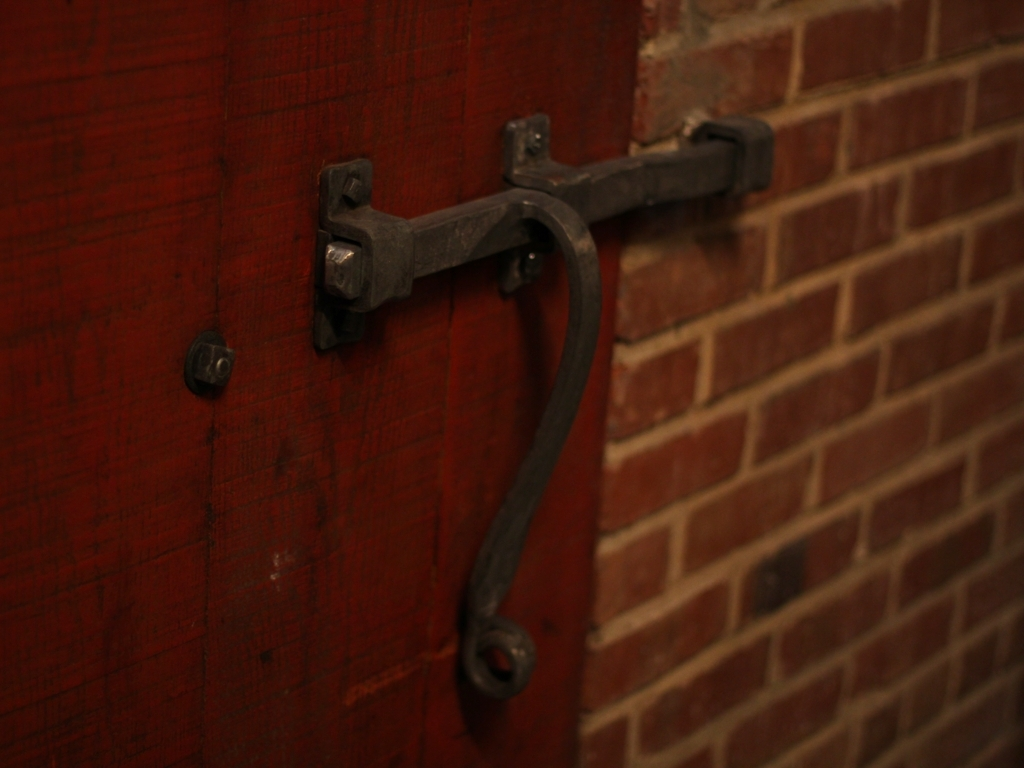What can be recognized about the main subject?
A. color details
B. shape details
C. size details
D. most of its texture details
Answer with the option's letter from the given choices directly. While the texture details of the latch and brick wall are prominent in the image, the deep red hue of the door also stands out, along with the dark iron of the latch contrasting sharply against the color. The shape of the latch is somewhat discernible, though the focus and composition obscure finer details, resulting in a less clear assessment of its shape and size. Therefore, the most accurate aspect that can be recognized is a combination of color and texture details, with an emphasis on D, the texture details. 